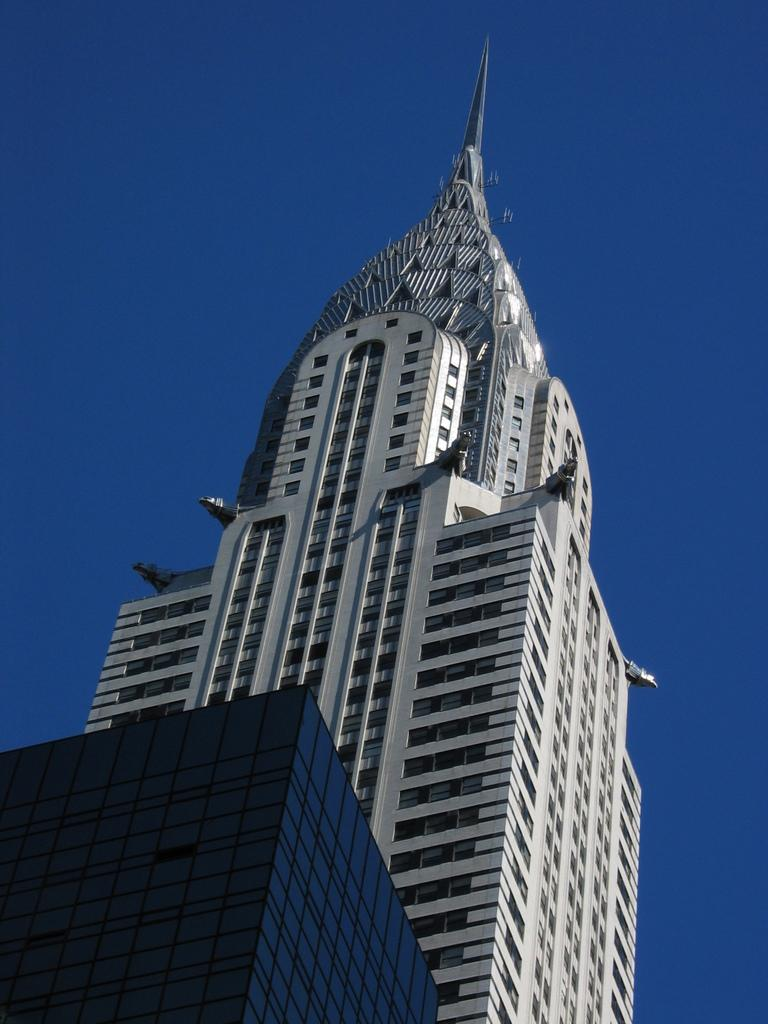What is the main subject of the image? The main subject of the image is a building. What specific features can be observed on the building? The building has windows. What can be seen in the background of the image? The sky is visible in the background of the image. What type of jelly can be seen on the windows of the building in the image? There is no jelly present on the windows of the building in the image. What type of apparel is the building wearing in the image? Buildings do not wear apparel, as they are inanimate objects. 